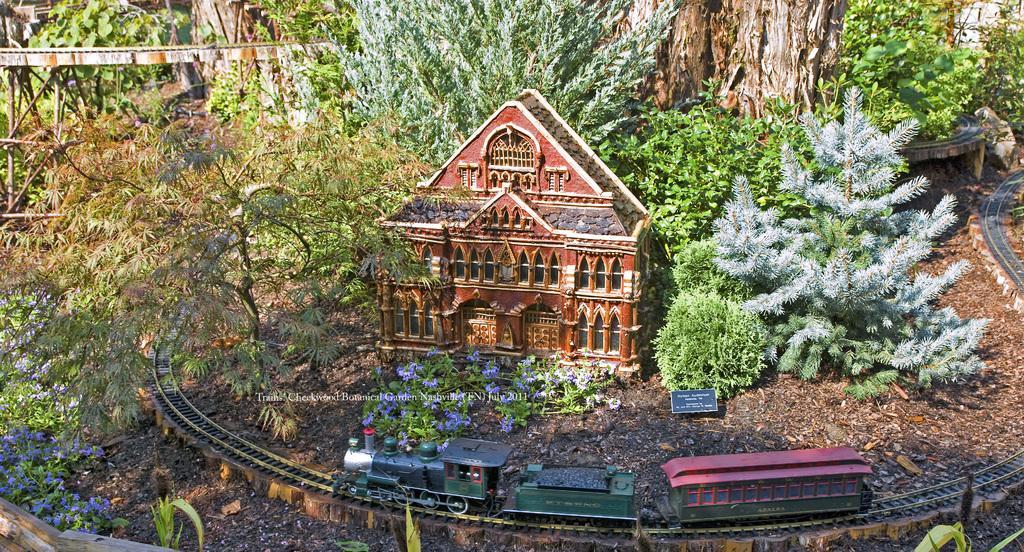Can you describe this image briefly? In this image I can see the train on the track and the train is in green and red color. Background I can see the building in brown color, trees in green color and I can see the bridge. 